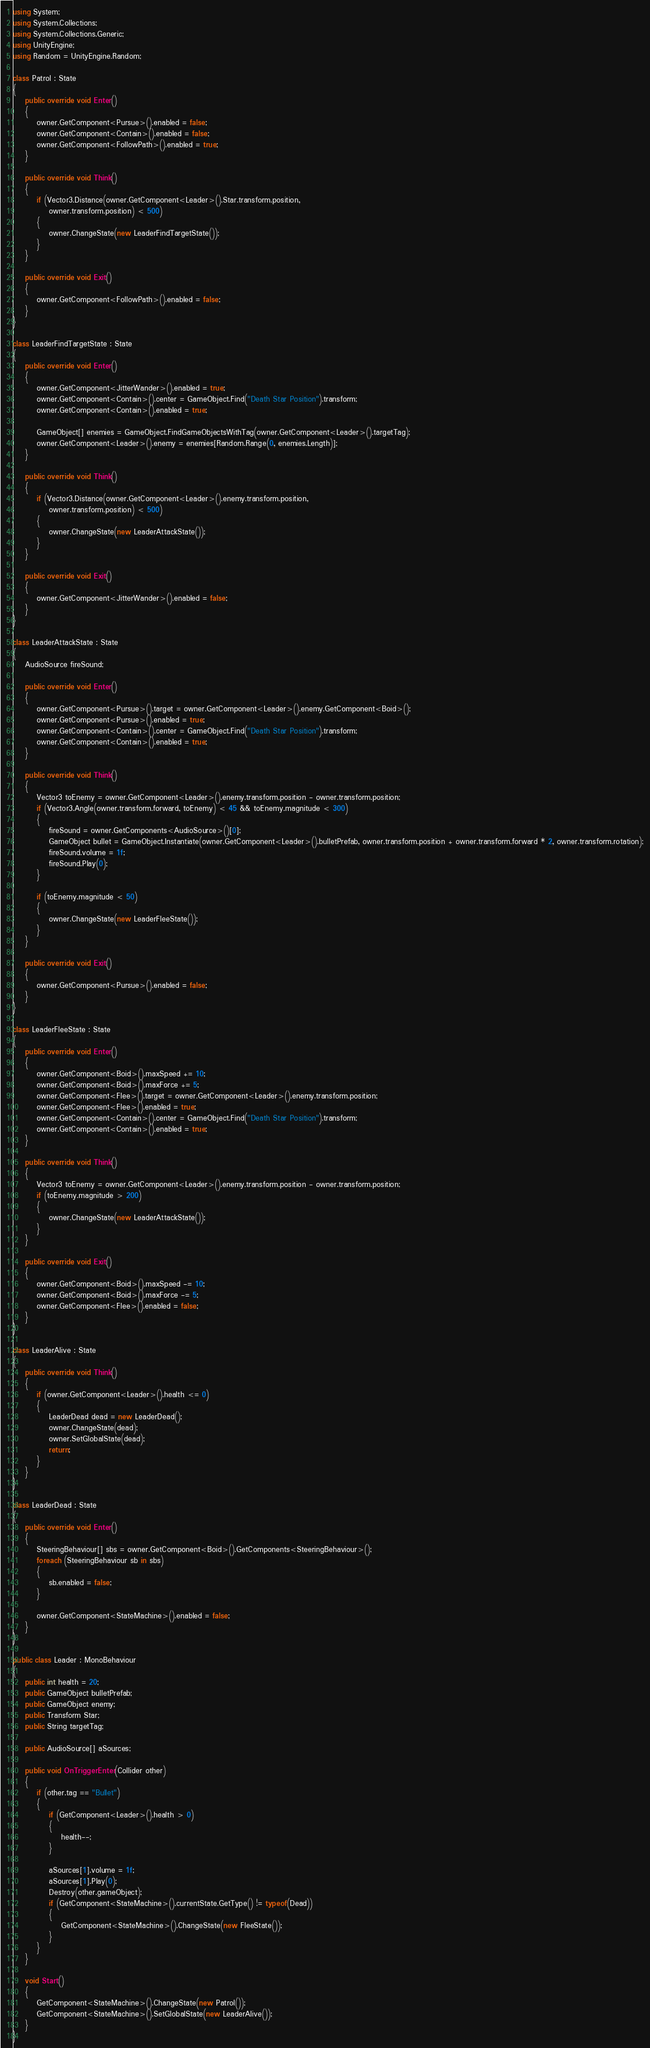Convert code to text. <code><loc_0><loc_0><loc_500><loc_500><_C#_>using System;
using System.Collections;
using System.Collections.Generic;
using UnityEngine;
using Random = UnityEngine.Random;

class Patrol : State
{
    public override void Enter()
    {
        owner.GetComponent<Pursue>().enabled = false;
        owner.GetComponent<Contain>().enabled = false;
        owner.GetComponent<FollowPath>().enabled = true;
    }
    
    public override void Think()
    {
        if (Vector3.Distance(owner.GetComponent<Leader>().Star.transform.position,
            owner.transform.position) < 500)
        {
            owner.ChangeState(new LeaderFindTargetState());
        }
    }

    public override void Exit()
    {
        owner.GetComponent<FollowPath>().enabled = false;
    }
}

class LeaderFindTargetState : State
{
    public override void Enter()
    {
        owner.GetComponent<JitterWander>().enabled = true;
        owner.GetComponent<Contain>().center = GameObject.Find("Death Star Position").transform;
        owner.GetComponent<Contain>().enabled = true;
        
        GameObject[] enemies = GameObject.FindGameObjectsWithTag(owner.GetComponent<Leader>().targetTag);
        owner.GetComponent<Leader>().enemy = enemies[Random.Range(0, enemies.Length)];
    }

    public override void Think()
    {
        if (Vector3.Distance(owner.GetComponent<Leader>().enemy.transform.position,
            owner.transform.position) < 500)
        {
            owner.ChangeState(new LeaderAttackState());
        }
    }

    public override void Exit()
    {
        owner.GetComponent<JitterWander>().enabled = false;
    }
}

class LeaderAttackState : State
{
    AudioSource fireSound;
    
    public override void Enter()
    {
        owner.GetComponent<Pursue>().target = owner.GetComponent<Leader>().enemy.GetComponent<Boid>();
        owner.GetComponent<Pursue>().enabled = true;
        owner.GetComponent<Contain>().center = GameObject.Find("Death Star Position").transform;
        owner.GetComponent<Contain>().enabled = true;
    }

    public override void Think()
    {
        Vector3 toEnemy = owner.GetComponent<Leader>().enemy.transform.position - owner.transform.position;
        if (Vector3.Angle(owner.transform.forward, toEnemy) < 45 && toEnemy.magnitude < 300)
        {
            fireSound = owner.GetComponents<AudioSource>()[0];
            GameObject bullet = GameObject.Instantiate(owner.GetComponent<Leader>().bulletPrefab, owner.transform.position + owner.transform.forward * 2, owner.transform.rotation);
            fireSound.volume = 1f;
            fireSound.Play(0);
        }

        if (toEnemy.magnitude < 50)
        {
            owner.ChangeState(new LeaderFleeState());
        }
    }

    public override void Exit()
    {
        owner.GetComponent<Pursue>().enabled = false;
    }
}

class LeaderFleeState : State
{
    public override void Enter()
    {
        owner.GetComponent<Boid>().maxSpeed += 10;
        owner.GetComponent<Boid>().maxForce += 5;
        owner.GetComponent<Flee>().target = owner.GetComponent<Leader>().enemy.transform.position;
        owner.GetComponent<Flee>().enabled = true;
        owner.GetComponent<Contain>().center = GameObject.Find("Death Star Position").transform;
        owner.GetComponent<Contain>().enabled = true;
    }

    public override void Think()
    {
        Vector3 toEnemy = owner.GetComponent<Leader>().enemy.transform.position - owner.transform.position;
        if (toEnemy.magnitude > 200)
        {
            owner.ChangeState(new LeaderAttackState());
        }
    }

    public override void Exit()
    {
        owner.GetComponent<Boid>().maxSpeed -= 10;
        owner.GetComponent<Boid>().maxForce -= 5;
        owner.GetComponent<Flee>().enabled = false;
    }
}

class LeaderAlive : State
{
    public override void Think()
    {
        if (owner.GetComponent<Leader>().health <= 0)
        {
            LeaderDead dead = new LeaderDead();
            owner.ChangeState(dead);
            owner.SetGlobalState(dead);
            return;
        }
    }
}

class LeaderDead : State
{
    public override void Enter()
    {
        SteeringBehaviour[] sbs = owner.GetComponent<Boid>().GetComponents<SteeringBehaviour>();
        foreach (SteeringBehaviour sb in sbs)
        {
            sb.enabled = false;
        }

        owner.GetComponent<StateMachine>().enabled = false;
    }
}

public class Leader : MonoBehaviour
{
    public int health = 20;
    public GameObject bulletPrefab;
    public GameObject enemy;
    public Transform Star;
    public String targetTag;

    public AudioSource[] aSources;

    public void OnTriggerEnter(Collider other)
    {
        if (other.tag == "Bullet")
        {
            if (GetComponent<Leader>().health > 0)
            {
                health--;
            }

            aSources[1].volume = 1f;
            aSources[1].Play(0);
            Destroy(other.gameObject);
            if (GetComponent<StateMachine>().currentState.GetType() != typeof(Dead))
            {
                GetComponent<StateMachine>().ChangeState(new FleeState());
            }
        }
    }
    
    void Start()
    {
        GetComponent<StateMachine>().ChangeState(new Patrol());
        GetComponent<StateMachine>().SetGlobalState(new LeaderAlive());
    }
}
</code> 